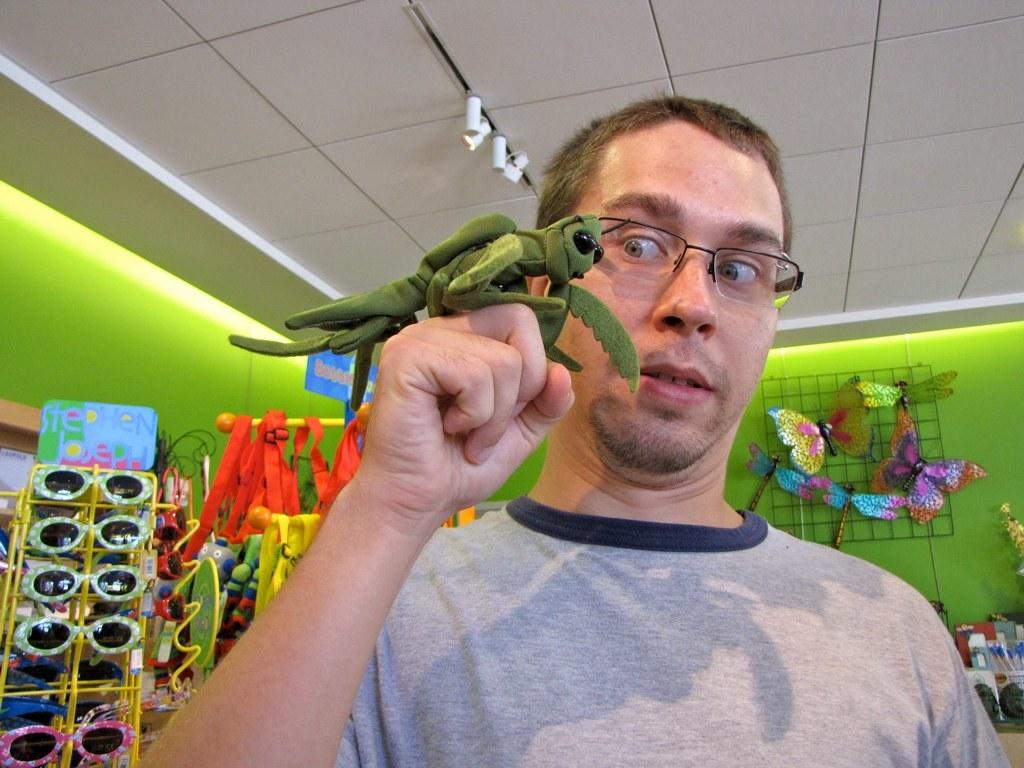What is the man in the image doing? The man is carrying an animal toy on his fist and looking at the animal toy. What type of toy is the man holding? The man is holding an animal toy. What can be seen in the background of the image? There are many toys in the background of the image, including goggles and butterflies. What direction is the man facing in the image? The facts provided do not mention the direction the man is facing, so it cannot be determined from the image. 